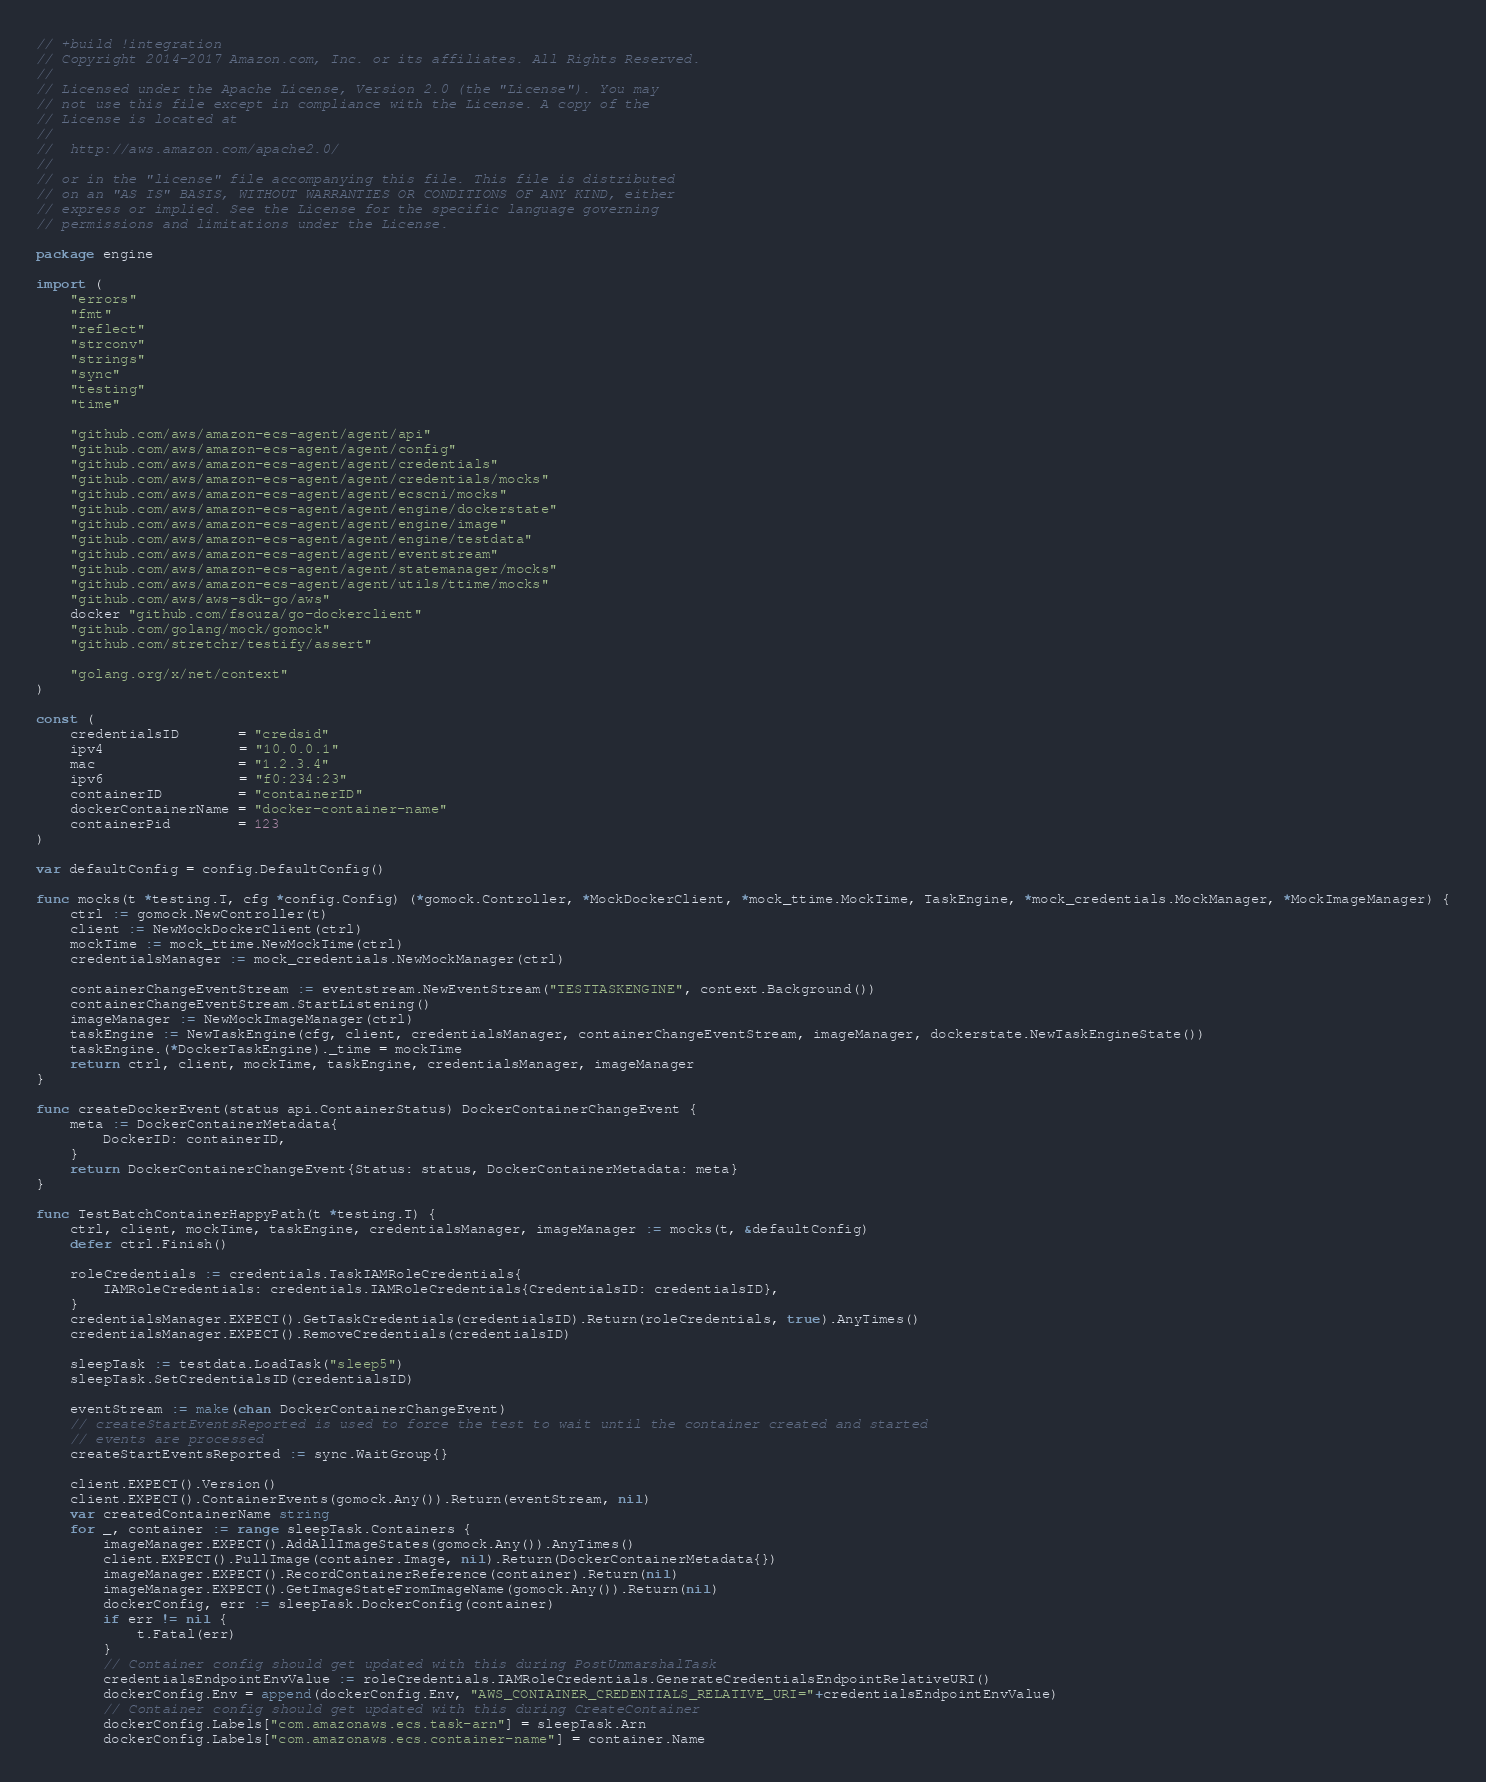<code> <loc_0><loc_0><loc_500><loc_500><_Go_>// +build !integration
// Copyright 2014-2017 Amazon.com, Inc. or its affiliates. All Rights Reserved.
//
// Licensed under the Apache License, Version 2.0 (the "License"). You may
// not use this file except in compliance with the License. A copy of the
// License is located at
//
//	http://aws.amazon.com/apache2.0/
//
// or in the "license" file accompanying this file. This file is distributed
// on an "AS IS" BASIS, WITHOUT WARRANTIES OR CONDITIONS OF ANY KIND, either
// express or implied. See the License for the specific language governing
// permissions and limitations under the License.

package engine

import (
	"errors"
	"fmt"
	"reflect"
	"strconv"
	"strings"
	"sync"
	"testing"
	"time"

	"github.com/aws/amazon-ecs-agent/agent/api"
	"github.com/aws/amazon-ecs-agent/agent/config"
	"github.com/aws/amazon-ecs-agent/agent/credentials"
	"github.com/aws/amazon-ecs-agent/agent/credentials/mocks"
	"github.com/aws/amazon-ecs-agent/agent/ecscni/mocks"
	"github.com/aws/amazon-ecs-agent/agent/engine/dockerstate"
	"github.com/aws/amazon-ecs-agent/agent/engine/image"
	"github.com/aws/amazon-ecs-agent/agent/engine/testdata"
	"github.com/aws/amazon-ecs-agent/agent/eventstream"
	"github.com/aws/amazon-ecs-agent/agent/statemanager/mocks"
	"github.com/aws/amazon-ecs-agent/agent/utils/ttime/mocks"
	"github.com/aws/aws-sdk-go/aws"
	docker "github.com/fsouza/go-dockerclient"
	"github.com/golang/mock/gomock"
	"github.com/stretchr/testify/assert"

	"golang.org/x/net/context"
)

const (
	credentialsID       = "credsid"
	ipv4                = "10.0.0.1"
	mac                 = "1.2.3.4"
	ipv6                = "f0:234:23"
	containerID         = "containerID"
	dockerContainerName = "docker-container-name"
	containerPid        = 123
)

var defaultConfig = config.DefaultConfig()

func mocks(t *testing.T, cfg *config.Config) (*gomock.Controller, *MockDockerClient, *mock_ttime.MockTime, TaskEngine, *mock_credentials.MockManager, *MockImageManager) {
	ctrl := gomock.NewController(t)
	client := NewMockDockerClient(ctrl)
	mockTime := mock_ttime.NewMockTime(ctrl)
	credentialsManager := mock_credentials.NewMockManager(ctrl)

	containerChangeEventStream := eventstream.NewEventStream("TESTTASKENGINE", context.Background())
	containerChangeEventStream.StartListening()
	imageManager := NewMockImageManager(ctrl)
	taskEngine := NewTaskEngine(cfg, client, credentialsManager, containerChangeEventStream, imageManager, dockerstate.NewTaskEngineState())
	taskEngine.(*DockerTaskEngine)._time = mockTime
	return ctrl, client, mockTime, taskEngine, credentialsManager, imageManager
}

func createDockerEvent(status api.ContainerStatus) DockerContainerChangeEvent {
	meta := DockerContainerMetadata{
		DockerID: containerID,
	}
	return DockerContainerChangeEvent{Status: status, DockerContainerMetadata: meta}
}

func TestBatchContainerHappyPath(t *testing.T) {
	ctrl, client, mockTime, taskEngine, credentialsManager, imageManager := mocks(t, &defaultConfig)
	defer ctrl.Finish()

	roleCredentials := credentials.TaskIAMRoleCredentials{
		IAMRoleCredentials: credentials.IAMRoleCredentials{CredentialsID: credentialsID},
	}
	credentialsManager.EXPECT().GetTaskCredentials(credentialsID).Return(roleCredentials, true).AnyTimes()
	credentialsManager.EXPECT().RemoveCredentials(credentialsID)

	sleepTask := testdata.LoadTask("sleep5")
	sleepTask.SetCredentialsID(credentialsID)

	eventStream := make(chan DockerContainerChangeEvent)
	// createStartEventsReported is used to force the test to wait until the container created and started
	// events are processed
	createStartEventsReported := sync.WaitGroup{}

	client.EXPECT().Version()
	client.EXPECT().ContainerEvents(gomock.Any()).Return(eventStream, nil)
	var createdContainerName string
	for _, container := range sleepTask.Containers {
		imageManager.EXPECT().AddAllImageStates(gomock.Any()).AnyTimes()
		client.EXPECT().PullImage(container.Image, nil).Return(DockerContainerMetadata{})
		imageManager.EXPECT().RecordContainerReference(container).Return(nil)
		imageManager.EXPECT().GetImageStateFromImageName(gomock.Any()).Return(nil)
		dockerConfig, err := sleepTask.DockerConfig(container)
		if err != nil {
			t.Fatal(err)
		}
		// Container config should get updated with this during PostUnmarshalTask
		credentialsEndpointEnvValue := roleCredentials.IAMRoleCredentials.GenerateCredentialsEndpointRelativeURI()
		dockerConfig.Env = append(dockerConfig.Env, "AWS_CONTAINER_CREDENTIALS_RELATIVE_URI="+credentialsEndpointEnvValue)
		// Container config should get updated with this during CreateContainer
		dockerConfig.Labels["com.amazonaws.ecs.task-arn"] = sleepTask.Arn
		dockerConfig.Labels["com.amazonaws.ecs.container-name"] = container.Name</code> 